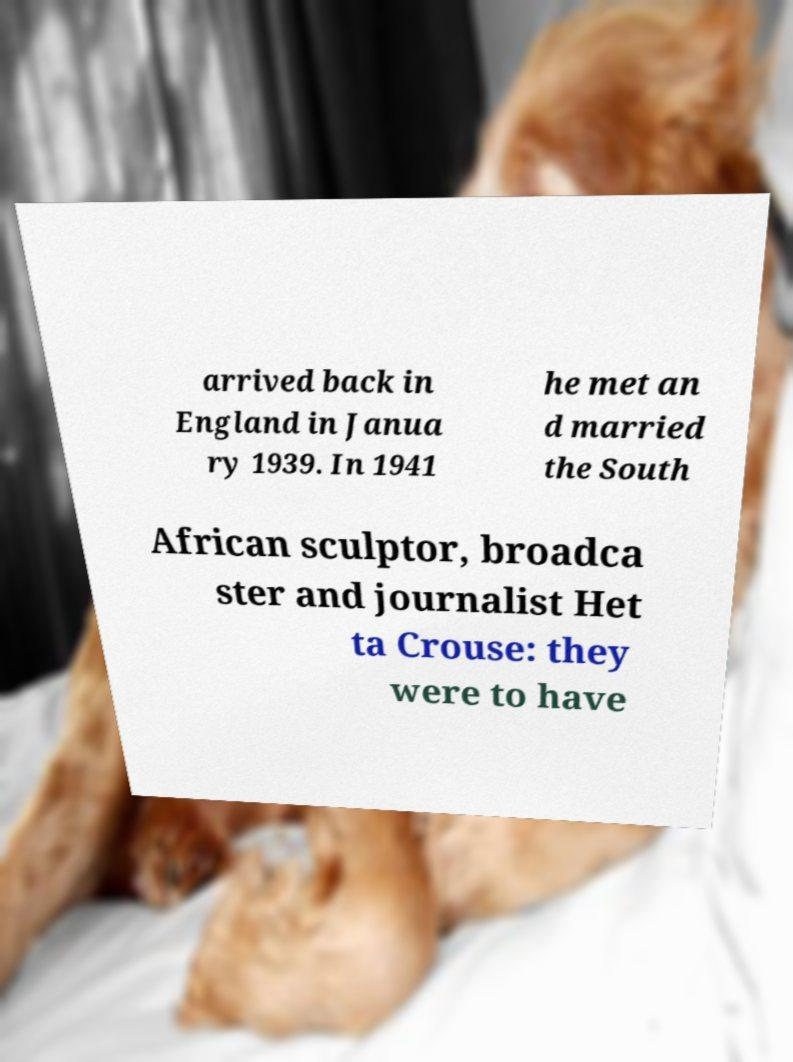I need the written content from this picture converted into text. Can you do that? arrived back in England in Janua ry 1939. In 1941 he met an d married the South African sculptor, broadca ster and journalist Het ta Crouse: they were to have 